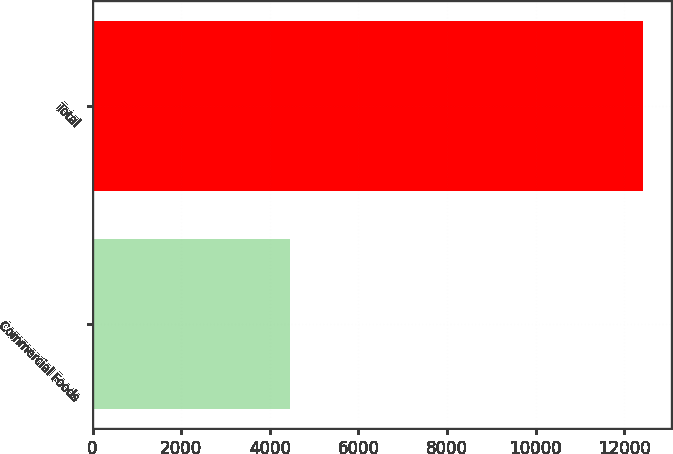Convert chart. <chart><loc_0><loc_0><loc_500><loc_500><bar_chart><fcel>Commercial Foods<fcel>Total<nl><fcel>4447<fcel>12426<nl></chart> 